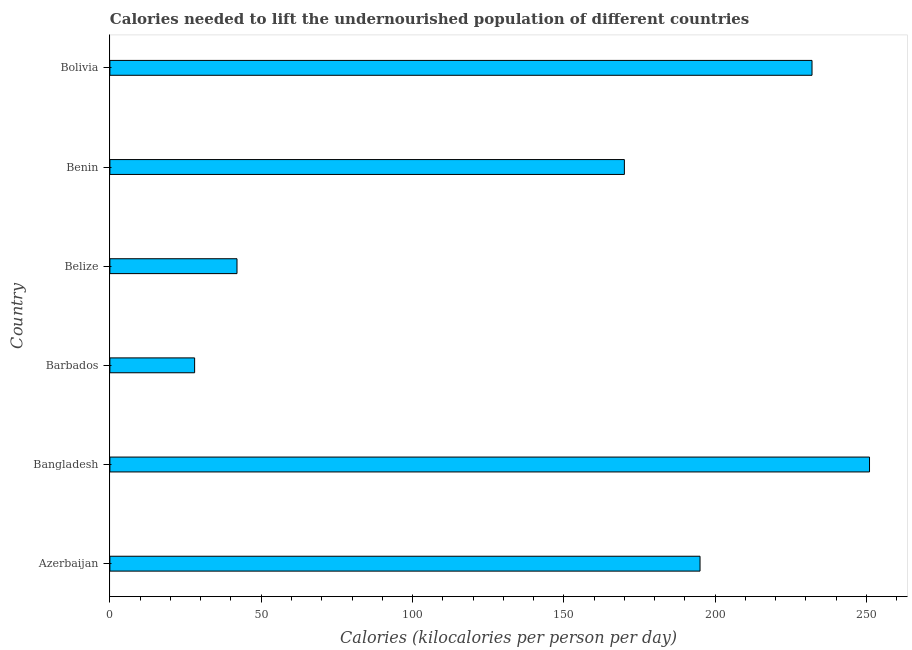What is the title of the graph?
Your answer should be very brief. Calories needed to lift the undernourished population of different countries. What is the label or title of the X-axis?
Provide a short and direct response. Calories (kilocalories per person per day). What is the depth of food deficit in Bolivia?
Give a very brief answer. 232. Across all countries, what is the maximum depth of food deficit?
Ensure brevity in your answer.  251. In which country was the depth of food deficit maximum?
Offer a very short reply. Bangladesh. In which country was the depth of food deficit minimum?
Your answer should be very brief. Barbados. What is the sum of the depth of food deficit?
Provide a succinct answer. 918. What is the difference between the depth of food deficit in Barbados and Bolivia?
Your response must be concise. -204. What is the average depth of food deficit per country?
Provide a succinct answer. 153. What is the median depth of food deficit?
Give a very brief answer. 182.5. What is the ratio of the depth of food deficit in Azerbaijan to that in Benin?
Ensure brevity in your answer.  1.15. Is the depth of food deficit in Azerbaijan less than that in Barbados?
Provide a short and direct response. No. What is the difference between the highest and the second highest depth of food deficit?
Make the answer very short. 19. Is the sum of the depth of food deficit in Bangladesh and Belize greater than the maximum depth of food deficit across all countries?
Give a very brief answer. Yes. What is the difference between the highest and the lowest depth of food deficit?
Make the answer very short. 223. In how many countries, is the depth of food deficit greater than the average depth of food deficit taken over all countries?
Provide a short and direct response. 4. How many bars are there?
Provide a succinct answer. 6. What is the Calories (kilocalories per person per day) in Azerbaijan?
Provide a succinct answer. 195. What is the Calories (kilocalories per person per day) in Bangladesh?
Your answer should be compact. 251. What is the Calories (kilocalories per person per day) in Belize?
Offer a terse response. 42. What is the Calories (kilocalories per person per day) of Benin?
Keep it short and to the point. 170. What is the Calories (kilocalories per person per day) of Bolivia?
Ensure brevity in your answer.  232. What is the difference between the Calories (kilocalories per person per day) in Azerbaijan and Bangladesh?
Your response must be concise. -56. What is the difference between the Calories (kilocalories per person per day) in Azerbaijan and Barbados?
Provide a short and direct response. 167. What is the difference between the Calories (kilocalories per person per day) in Azerbaijan and Belize?
Give a very brief answer. 153. What is the difference between the Calories (kilocalories per person per day) in Azerbaijan and Benin?
Offer a terse response. 25. What is the difference between the Calories (kilocalories per person per day) in Azerbaijan and Bolivia?
Offer a terse response. -37. What is the difference between the Calories (kilocalories per person per day) in Bangladesh and Barbados?
Provide a short and direct response. 223. What is the difference between the Calories (kilocalories per person per day) in Bangladesh and Belize?
Provide a succinct answer. 209. What is the difference between the Calories (kilocalories per person per day) in Bangladesh and Benin?
Your answer should be compact. 81. What is the difference between the Calories (kilocalories per person per day) in Bangladesh and Bolivia?
Your answer should be compact. 19. What is the difference between the Calories (kilocalories per person per day) in Barbados and Belize?
Provide a short and direct response. -14. What is the difference between the Calories (kilocalories per person per day) in Barbados and Benin?
Your response must be concise. -142. What is the difference between the Calories (kilocalories per person per day) in Barbados and Bolivia?
Offer a very short reply. -204. What is the difference between the Calories (kilocalories per person per day) in Belize and Benin?
Make the answer very short. -128. What is the difference between the Calories (kilocalories per person per day) in Belize and Bolivia?
Provide a short and direct response. -190. What is the difference between the Calories (kilocalories per person per day) in Benin and Bolivia?
Your answer should be very brief. -62. What is the ratio of the Calories (kilocalories per person per day) in Azerbaijan to that in Bangladesh?
Your answer should be compact. 0.78. What is the ratio of the Calories (kilocalories per person per day) in Azerbaijan to that in Barbados?
Keep it short and to the point. 6.96. What is the ratio of the Calories (kilocalories per person per day) in Azerbaijan to that in Belize?
Keep it short and to the point. 4.64. What is the ratio of the Calories (kilocalories per person per day) in Azerbaijan to that in Benin?
Give a very brief answer. 1.15. What is the ratio of the Calories (kilocalories per person per day) in Azerbaijan to that in Bolivia?
Offer a terse response. 0.84. What is the ratio of the Calories (kilocalories per person per day) in Bangladesh to that in Barbados?
Provide a short and direct response. 8.96. What is the ratio of the Calories (kilocalories per person per day) in Bangladesh to that in Belize?
Ensure brevity in your answer.  5.98. What is the ratio of the Calories (kilocalories per person per day) in Bangladesh to that in Benin?
Provide a short and direct response. 1.48. What is the ratio of the Calories (kilocalories per person per day) in Bangladesh to that in Bolivia?
Give a very brief answer. 1.08. What is the ratio of the Calories (kilocalories per person per day) in Barbados to that in Belize?
Give a very brief answer. 0.67. What is the ratio of the Calories (kilocalories per person per day) in Barbados to that in Benin?
Offer a terse response. 0.17. What is the ratio of the Calories (kilocalories per person per day) in Barbados to that in Bolivia?
Provide a short and direct response. 0.12. What is the ratio of the Calories (kilocalories per person per day) in Belize to that in Benin?
Your answer should be very brief. 0.25. What is the ratio of the Calories (kilocalories per person per day) in Belize to that in Bolivia?
Offer a terse response. 0.18. What is the ratio of the Calories (kilocalories per person per day) in Benin to that in Bolivia?
Your response must be concise. 0.73. 